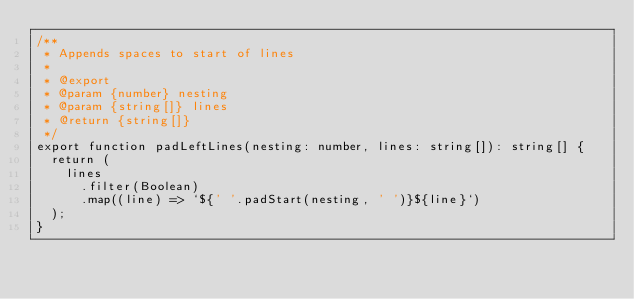<code> <loc_0><loc_0><loc_500><loc_500><_TypeScript_>/**
 * Appends spaces to start of lines
 *
 * @export
 * @param {number} nesting
 * @param {string[]} lines
 * @return {string[]}
 */
export function padLeftLines(nesting: number, lines: string[]): string[] {
  return (
    lines
      .filter(Boolean)
      .map((line) => `${' '.padStart(nesting, ' ')}${line}`)
  );
}
</code> 